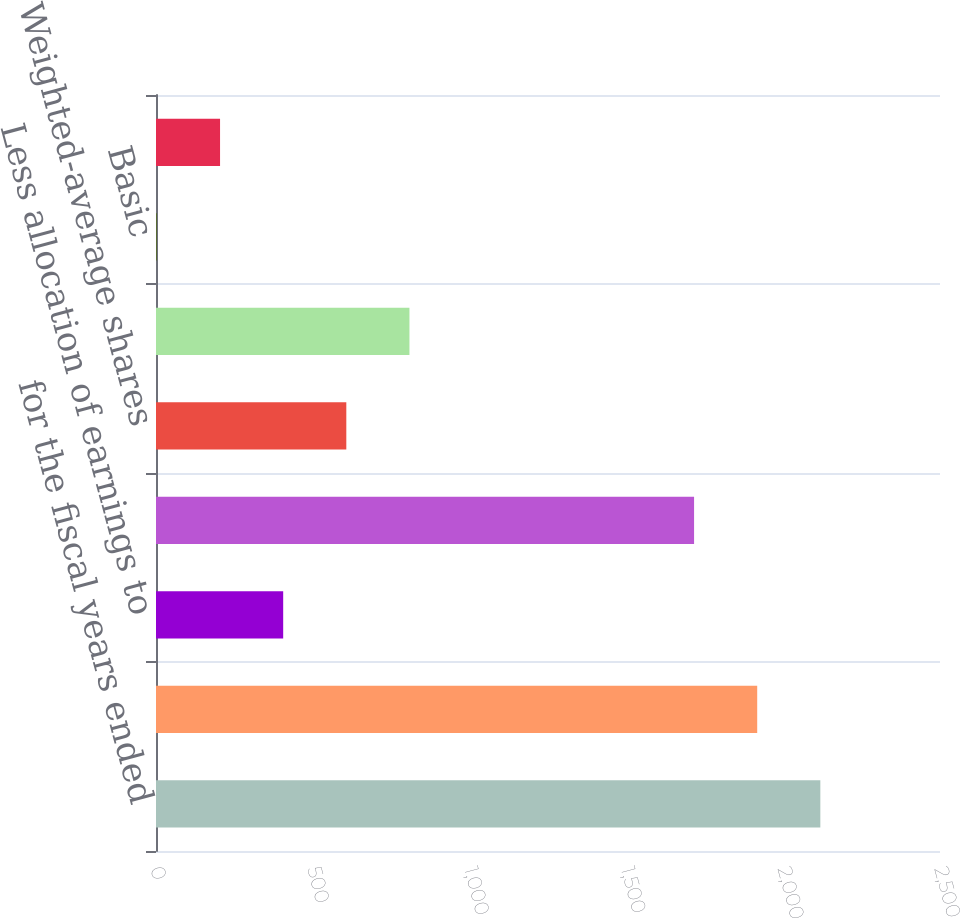<chart> <loc_0><loc_0><loc_500><loc_500><bar_chart><fcel>for the fiscal years ended<fcel>Net income attributable to<fcel>Less allocation of earnings to<fcel>Net Income Available to Common<fcel>Weighted-average shares<fcel>Weighted-Average Shares<fcel>Basic<fcel>Diluted<nl><fcel>2118.42<fcel>1917.11<fcel>405.56<fcel>1715.8<fcel>606.87<fcel>808.18<fcel>2.94<fcel>204.25<nl></chart> 